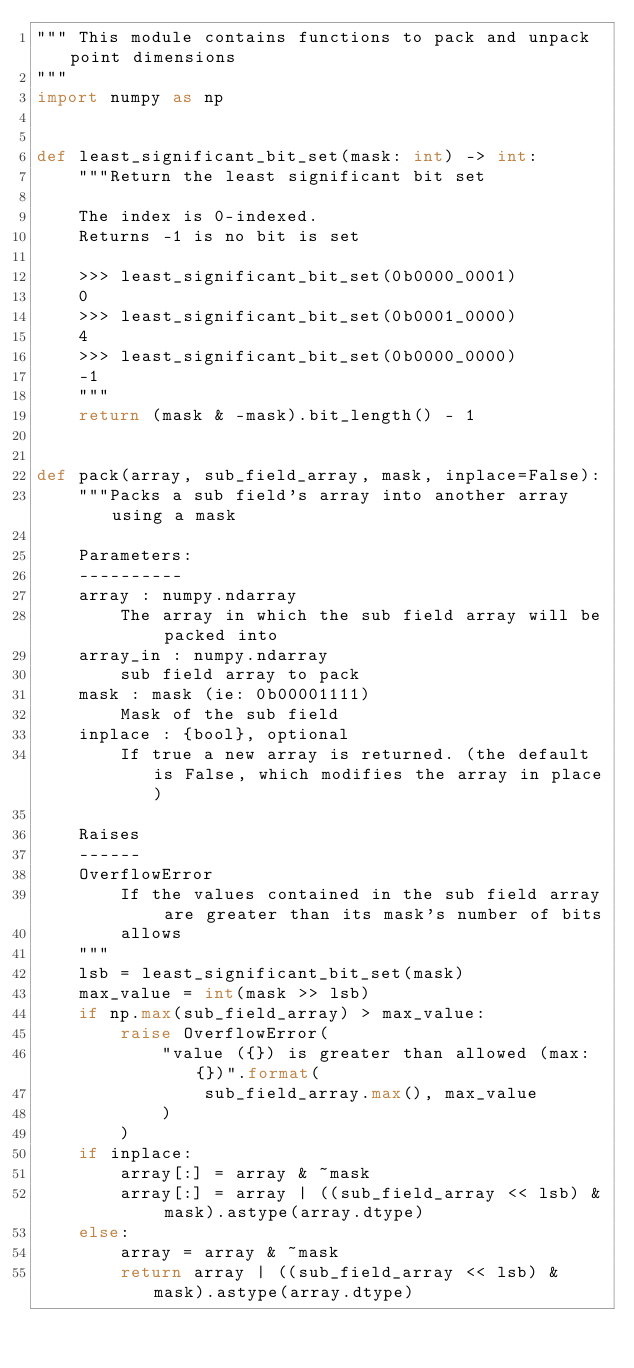Convert code to text. <code><loc_0><loc_0><loc_500><loc_500><_Python_>""" This module contains functions to pack and unpack point dimensions
"""
import numpy as np


def least_significant_bit_set(mask: int) -> int:
    """Return the least significant bit set

    The index is 0-indexed.
    Returns -1 is no bit is set

    >>> least_significant_bit_set(0b0000_0001)
    0
    >>> least_significant_bit_set(0b0001_0000)
    4
    >>> least_significant_bit_set(0b0000_0000)
    -1
    """
    return (mask & -mask).bit_length() - 1


def pack(array, sub_field_array, mask, inplace=False):
    """Packs a sub field's array into another array using a mask

    Parameters:
    ----------
    array : numpy.ndarray
        The array in which the sub field array will be packed into
    array_in : numpy.ndarray
        sub field array to pack
    mask : mask (ie: 0b00001111)
        Mask of the sub field
    inplace : {bool}, optional
        If true a new array is returned. (the default is False, which modifies the array in place)

    Raises
    ------
    OverflowError
        If the values contained in the sub field array are greater than its mask's number of bits
        allows
    """
    lsb = least_significant_bit_set(mask)
    max_value = int(mask >> lsb)
    if np.max(sub_field_array) > max_value:
        raise OverflowError(
            "value ({}) is greater than allowed (max: {})".format(
                sub_field_array.max(), max_value
            )
        )
    if inplace:
        array[:] = array & ~mask
        array[:] = array | ((sub_field_array << lsb) & mask).astype(array.dtype)
    else:
        array = array & ~mask
        return array | ((sub_field_array << lsb) & mask).astype(array.dtype)
</code> 